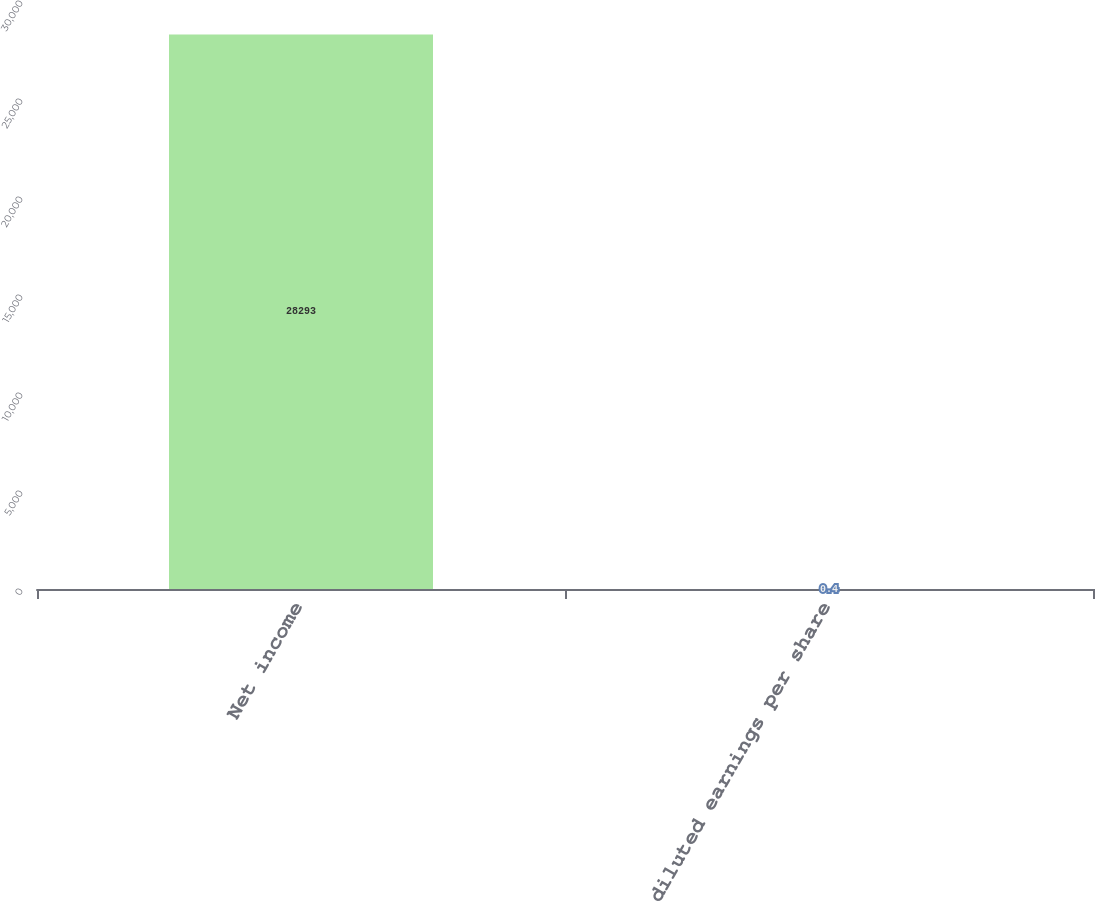Convert chart to OTSL. <chart><loc_0><loc_0><loc_500><loc_500><bar_chart><fcel>Net income<fcel>diluted earnings per share<nl><fcel>28293<fcel>0.4<nl></chart> 